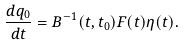Convert formula to latex. <formula><loc_0><loc_0><loc_500><loc_500>\frac { d q _ { 0 } } { d t } = B ^ { - 1 } ( t , t _ { 0 } ) F ( t ) \eta ( t ) .</formula> 